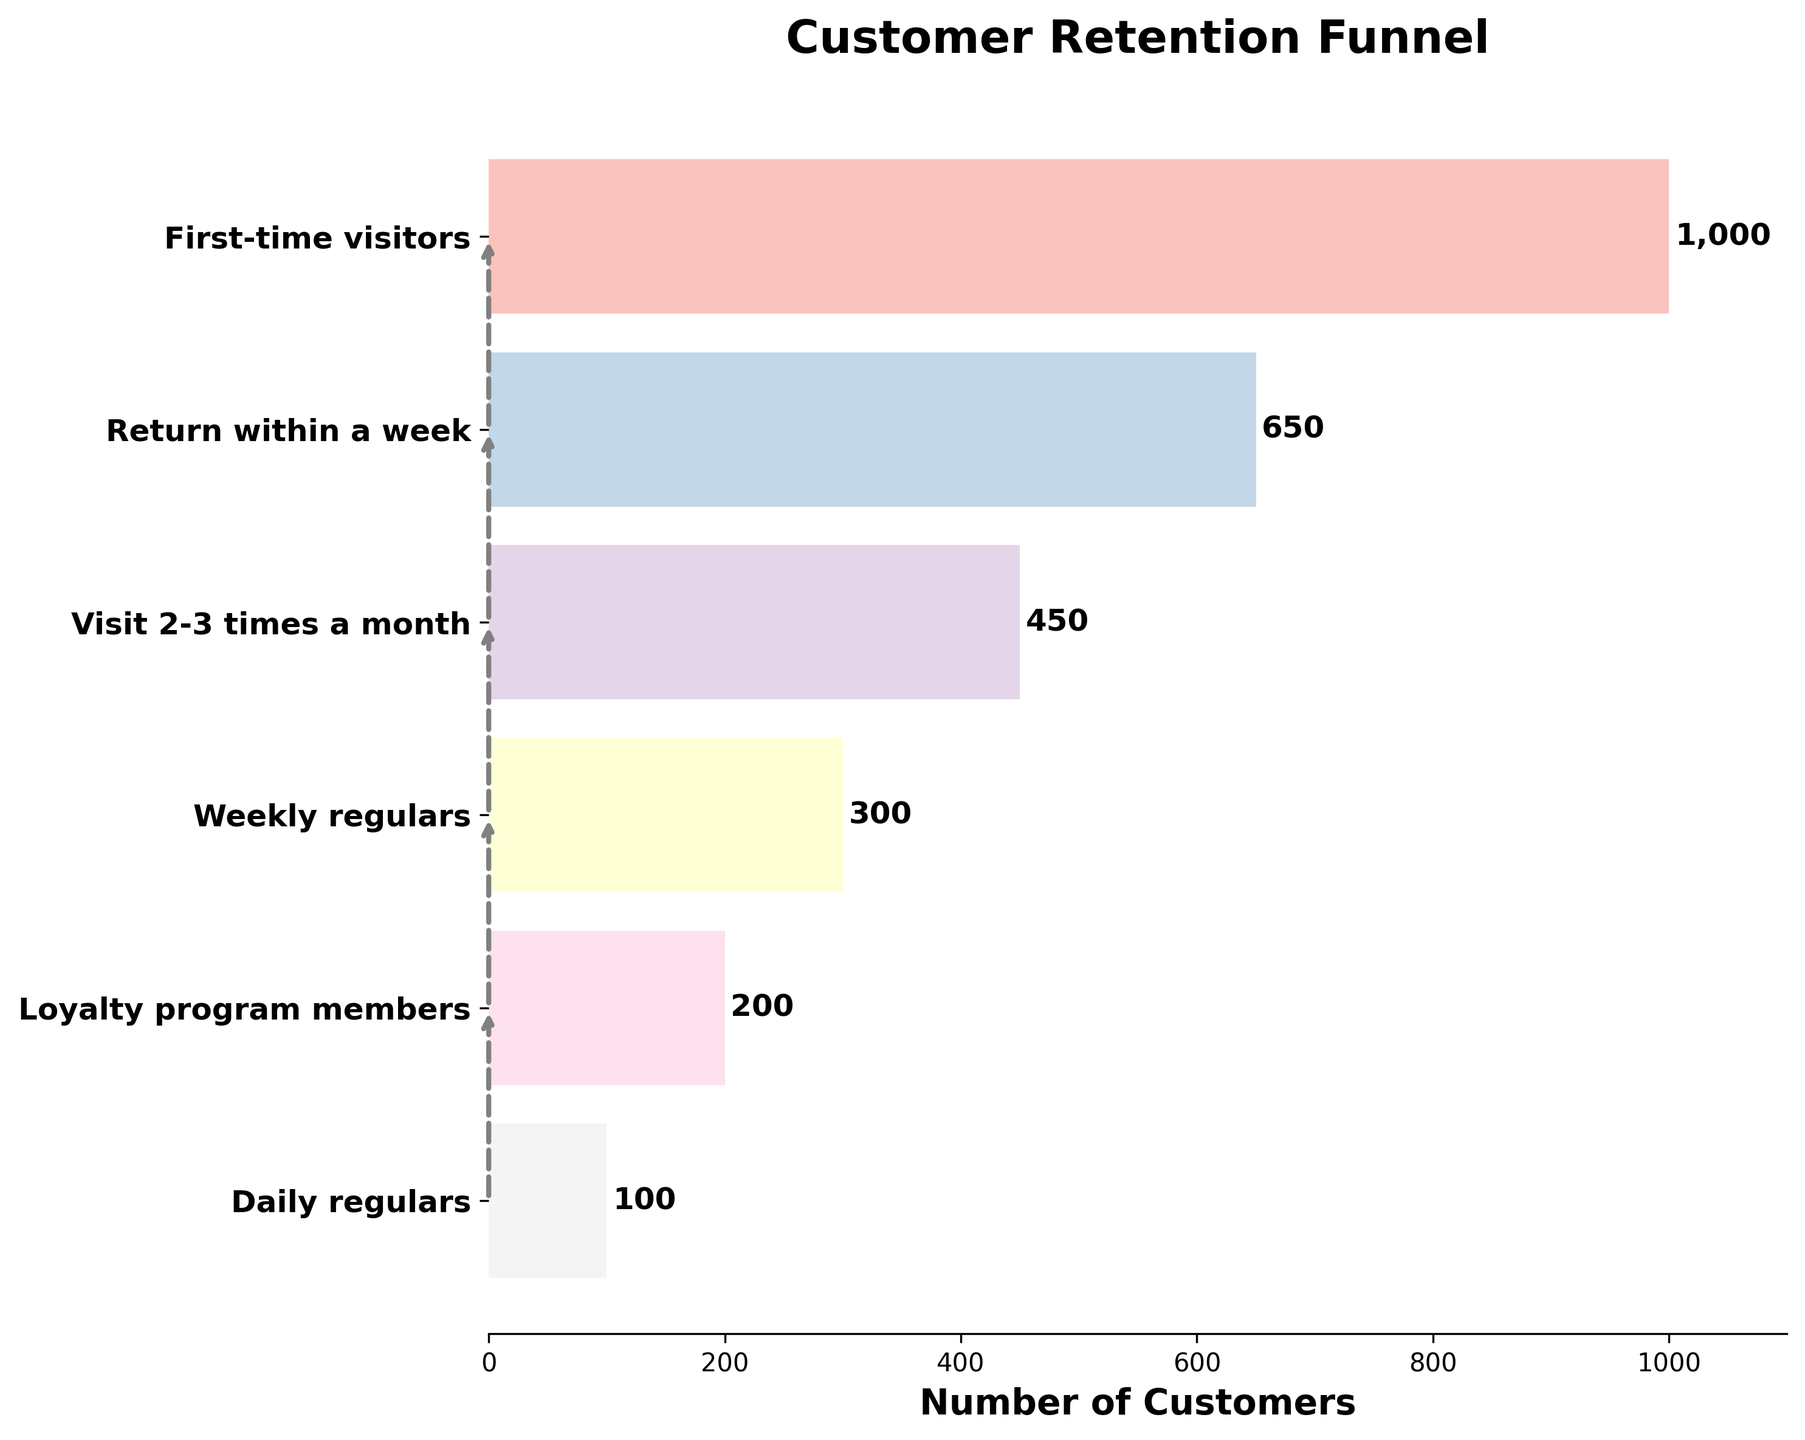what is the title of the chart? The title of the chart is displayed on the top of the figure. By reading it, we can determine the main subject of the chart.
Answer: Customer Retention Funnel How many stages are there in the funnel? By counting the number of distinct stages labeled on the y-axis of the chart, we can determine how many stages are there.
Answer: Six Which stage has the highest number of customers? The bar representing the 'First-time visitors' stage is the longest. This indicates that this stage has the highest number of customers.
Answer: First-time visitors Which stage has the lowest number of customers? The bar representing the 'Daily regulars' stage is the shortest. This indicates that this stage has the lowest number of customers.
Answer: Daily regulars How many customers return within a week? By looking at the label of the corresponding bar on the chart, we can identify the number of customers who return within a week.
Answer: 650 What is the difference in the number of customers between 'First-time visitors' and 'Weekly regulars'? Subtract the number of 'Weekly regulars' from the number of 'First-time visitors': 1000 - 300 = 700
Answer: 700 How many customers remain after the 'Visit 2-3 times a month' stage? Summing up the number of customers from 'Weekly regulars', 'Loyalty program members', and 'Daily regulars' provides the total remaining customers: 300 + 200 + 100 = 600
Answer: 600 What percentage of 'First-time visitors' become 'Loyalty program members'? The percentage can be calculated by dividing the number of 'Loyalty program members' by the number of 'First-time visitors' and multiplying by 100: (200 / 1000) * 100 = 20%
Answer: 20% Which stage precedes the 'Weekly regulars' stage? By referring to the order of stages labeled on the y-axis, we can see that 'Visit 2-3 times a month' comes right before 'Weekly regulars'.
Answer: Visit 2-3 times a month Are there more customers in the 'Return within a week' stage or the cumulative number of customers in 'Loyalty program members' and 'Daily regulars'? Compare 650 (Return within a week) against the sum of 'Loyalty program members' and 'Daily regulars': 200 + 100 = 300; 650 > 300.
Answer: Return within a week 